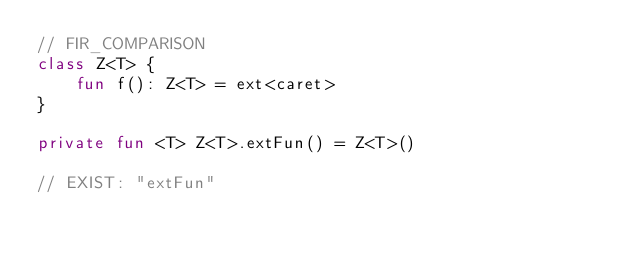Convert code to text. <code><loc_0><loc_0><loc_500><loc_500><_Kotlin_>// FIR_COMPARISON
class Z<T> {
    fun f(): Z<T> = ext<caret>
}

private fun <T> Z<T>.extFun() = Z<T>()

// EXIST: "extFun"
</code> 